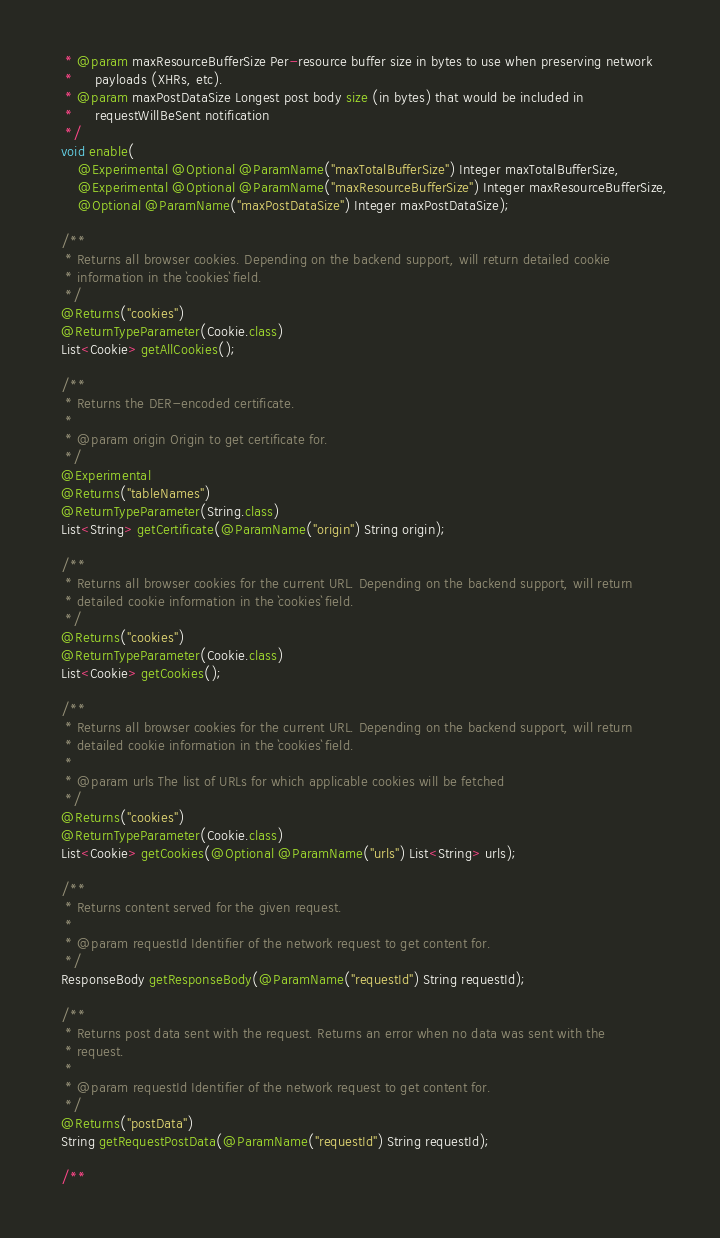Convert code to text. <code><loc_0><loc_0><loc_500><loc_500><_Java_>   * @param maxResourceBufferSize Per-resource buffer size in bytes to use when preserving network
   *     payloads (XHRs, etc).
   * @param maxPostDataSize Longest post body size (in bytes) that would be included in
   *     requestWillBeSent notification
   */
  void enable(
      @Experimental @Optional @ParamName("maxTotalBufferSize") Integer maxTotalBufferSize,
      @Experimental @Optional @ParamName("maxResourceBufferSize") Integer maxResourceBufferSize,
      @Optional @ParamName("maxPostDataSize") Integer maxPostDataSize);

  /**
   * Returns all browser cookies. Depending on the backend support, will return detailed cookie
   * information in the `cookies` field.
   */
  @Returns("cookies")
  @ReturnTypeParameter(Cookie.class)
  List<Cookie> getAllCookies();

  /**
   * Returns the DER-encoded certificate.
   *
   * @param origin Origin to get certificate for.
   */
  @Experimental
  @Returns("tableNames")
  @ReturnTypeParameter(String.class)
  List<String> getCertificate(@ParamName("origin") String origin);

  /**
   * Returns all browser cookies for the current URL. Depending on the backend support, will return
   * detailed cookie information in the `cookies` field.
   */
  @Returns("cookies")
  @ReturnTypeParameter(Cookie.class)
  List<Cookie> getCookies();

  /**
   * Returns all browser cookies for the current URL. Depending on the backend support, will return
   * detailed cookie information in the `cookies` field.
   *
   * @param urls The list of URLs for which applicable cookies will be fetched
   */
  @Returns("cookies")
  @ReturnTypeParameter(Cookie.class)
  List<Cookie> getCookies(@Optional @ParamName("urls") List<String> urls);

  /**
   * Returns content served for the given request.
   *
   * @param requestId Identifier of the network request to get content for.
   */
  ResponseBody getResponseBody(@ParamName("requestId") String requestId);

  /**
   * Returns post data sent with the request. Returns an error when no data was sent with the
   * request.
   *
   * @param requestId Identifier of the network request to get content for.
   */
  @Returns("postData")
  String getRequestPostData(@ParamName("requestId") String requestId);

  /**</code> 